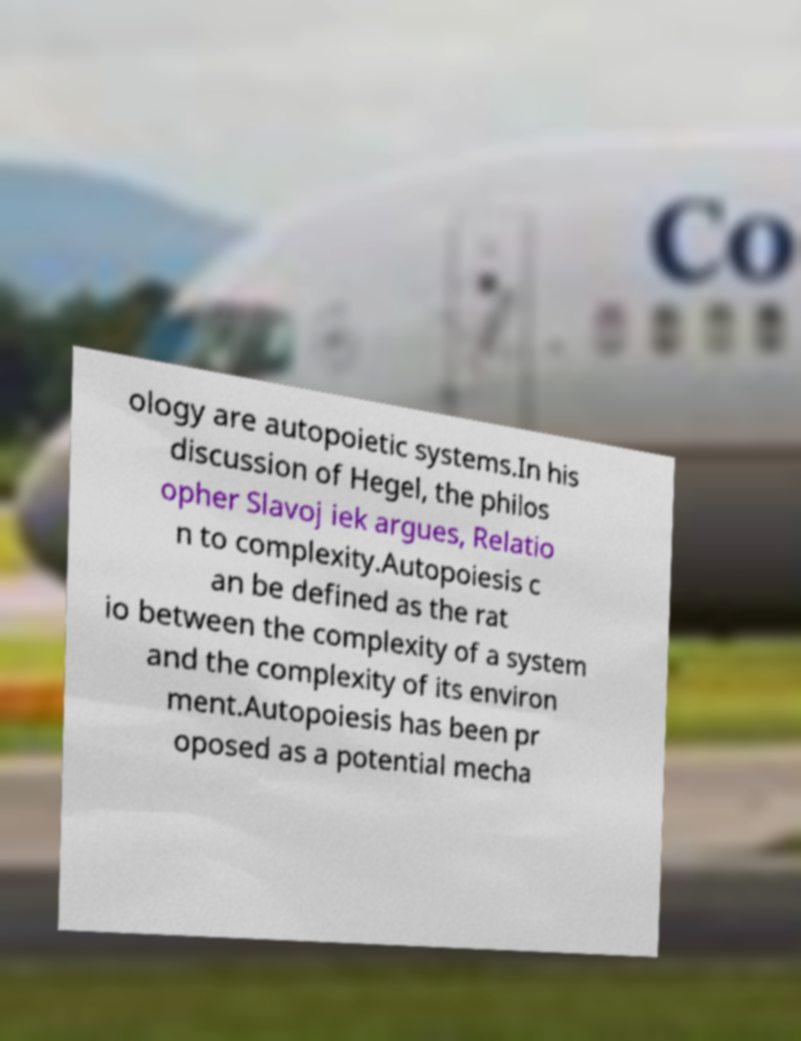What messages or text are displayed in this image? I need them in a readable, typed format. ology are autopoietic systems.In his discussion of Hegel, the philos opher Slavoj iek argues, Relatio n to complexity.Autopoiesis c an be defined as the rat io between the complexity of a system and the complexity of its environ ment.Autopoiesis has been pr oposed as a potential mecha 